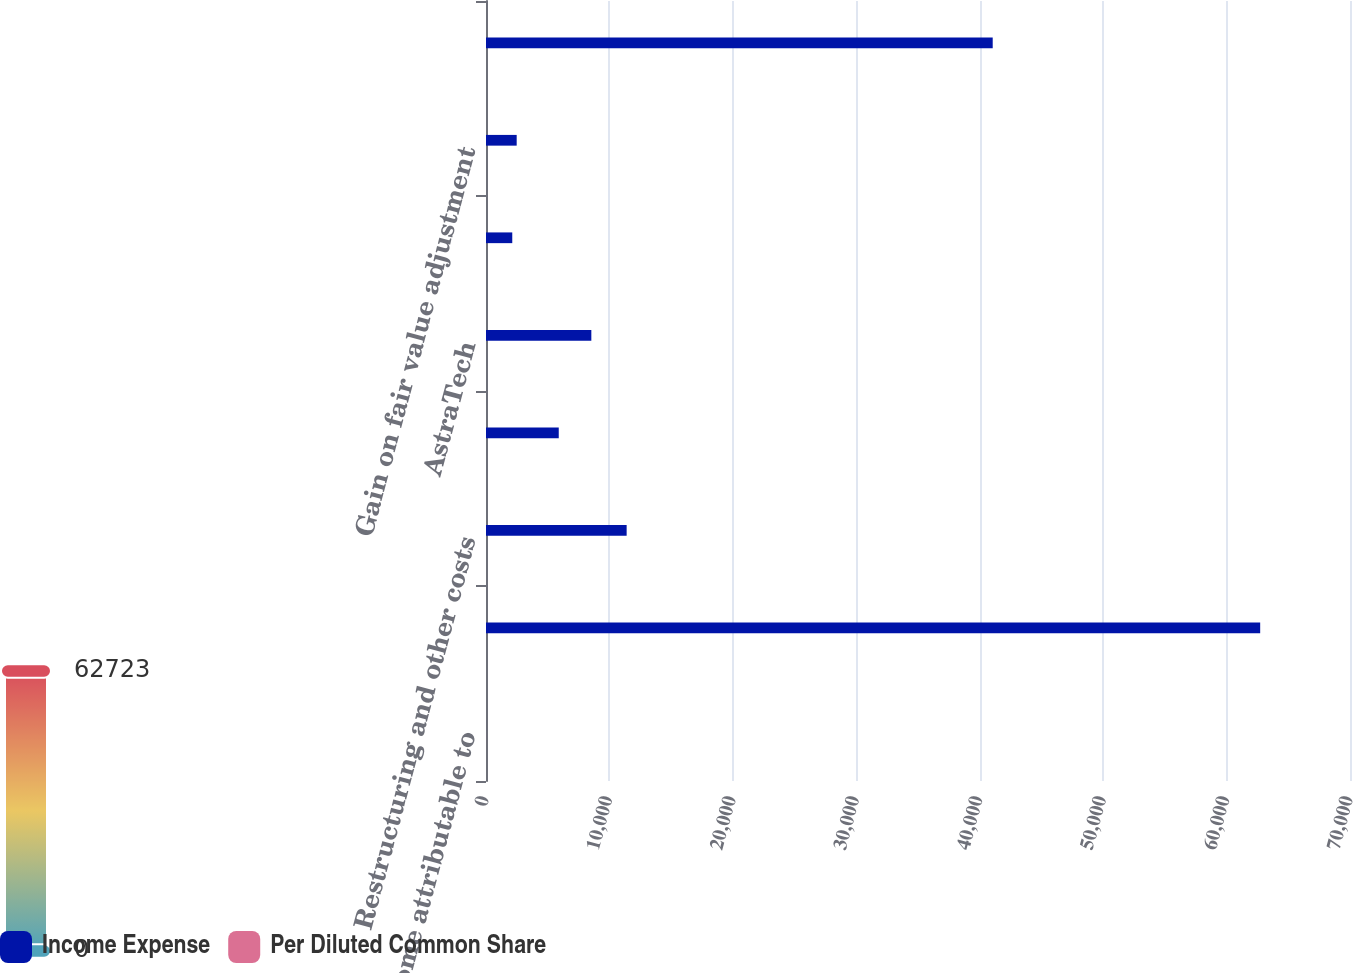<chart> <loc_0><loc_0><loc_500><loc_500><stacked_bar_chart><ecel><fcel>Net income attributable to<fcel>Acquisition related activities<fcel>Restructuring and other costs<fcel>Prior to July 1 2011<fcel>AstraTech<fcel>Orthodontic business<fcel>Gain on fair value adjustment<fcel>Income tax related adjustments<nl><fcel>Income Expense<fcel>1.7<fcel>62723<fcel>11395<fcel>5894<fcel>8534<fcel>2128<fcel>2486<fcel>41053<nl><fcel>Per Diluted Common Share<fcel>1.7<fcel>0.44<fcel>0.08<fcel>0.04<fcel>0.06<fcel>0.01<fcel>0.02<fcel>0.28<nl></chart> 